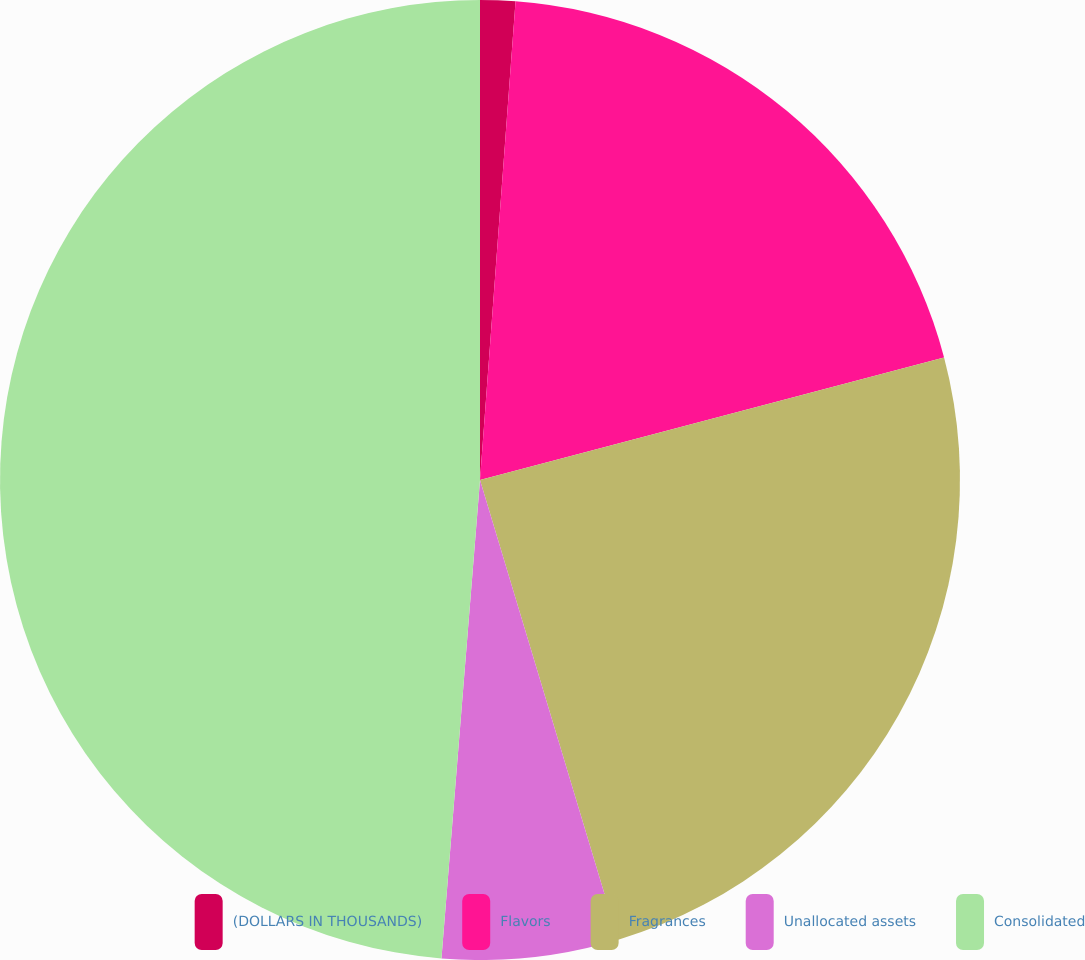<chart> <loc_0><loc_0><loc_500><loc_500><pie_chart><fcel>(DOLLARS IN THOUSANDS)<fcel>Flavors<fcel>Fragrances<fcel>Unallocated assets<fcel>Consolidated<nl><fcel>1.18%<fcel>19.71%<fcel>24.46%<fcel>5.93%<fcel>48.72%<nl></chart> 